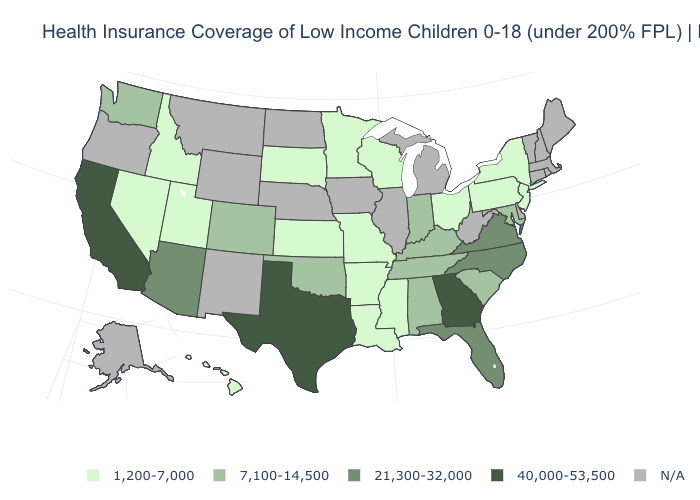What is the value of West Virginia?
Concise answer only. N/A. Is the legend a continuous bar?
Short answer required. No. Name the states that have a value in the range 7,100-14,500?
Quick response, please. Alabama, Colorado, Indiana, Kentucky, Maryland, Oklahoma, South Carolina, Tennessee, Washington. What is the value of Wyoming?
Answer briefly. N/A. Name the states that have a value in the range 1,200-7,000?
Be succinct. Arkansas, Hawaii, Idaho, Kansas, Louisiana, Minnesota, Mississippi, Missouri, Nevada, New Jersey, New York, Ohio, Pennsylvania, South Dakota, Utah, Wisconsin. Among the states that border Nebraska , does Colorado have the highest value?
Write a very short answer. Yes. What is the lowest value in the USA?
Answer briefly. 1,200-7,000. What is the value of New York?
Keep it brief. 1,200-7,000. Does California have the highest value in the USA?
Write a very short answer. Yes. Does Georgia have the highest value in the South?
Be succinct. Yes. What is the value of North Carolina?
Concise answer only. 21,300-32,000. What is the value of Connecticut?
Answer briefly. N/A. Does the first symbol in the legend represent the smallest category?
Short answer required. Yes. 